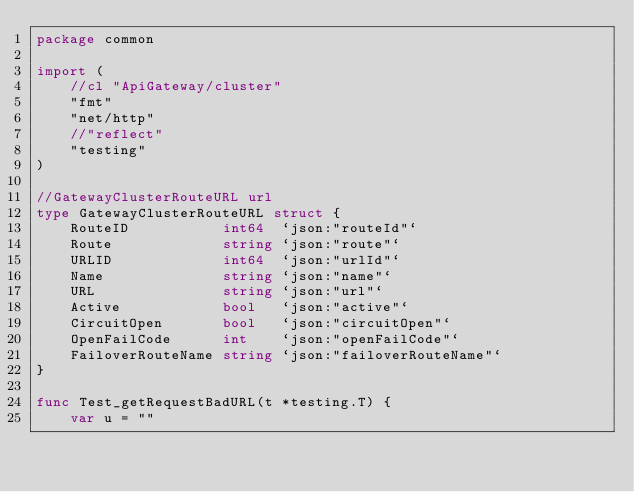<code> <loc_0><loc_0><loc_500><loc_500><_Go_>package common

import (
	//cl "ApiGateway/cluster"
	"fmt"
	"net/http"
	//"reflect"
	"testing"
)

//GatewayClusterRouteURL url
type GatewayClusterRouteURL struct {
	RouteID           int64  `json:"routeId"`
	Route             string `json:"route"`
	URLID             int64  `json:"urlId"`
	Name              string `json:"name"`
	URL               string `json:"url"`
	Active            bool   `json:"active"`
	CircuitOpen       bool   `json:"circuitOpen"`
	OpenFailCode      int    `json:"openFailCode"`
	FailoverRouteName string `json:"failoverRouteName"`
}

func Test_getRequestBadURL(t *testing.T) {
	var u = ""</code> 